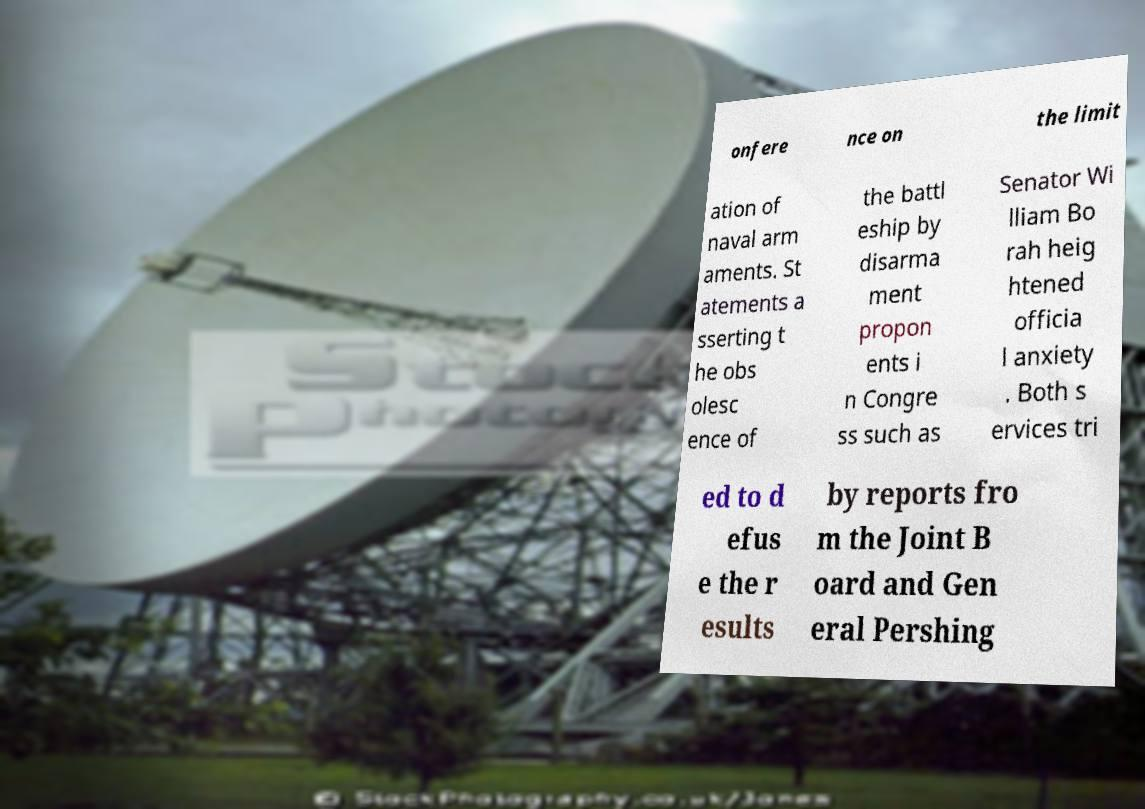Please read and relay the text visible in this image. What does it say? onfere nce on the limit ation of naval arm aments. St atements a sserting t he obs olesc ence of the battl eship by disarma ment propon ents i n Congre ss such as Senator Wi lliam Bo rah heig htened officia l anxiety . Both s ervices tri ed to d efus e the r esults by reports fro m the Joint B oard and Gen eral Pershing 